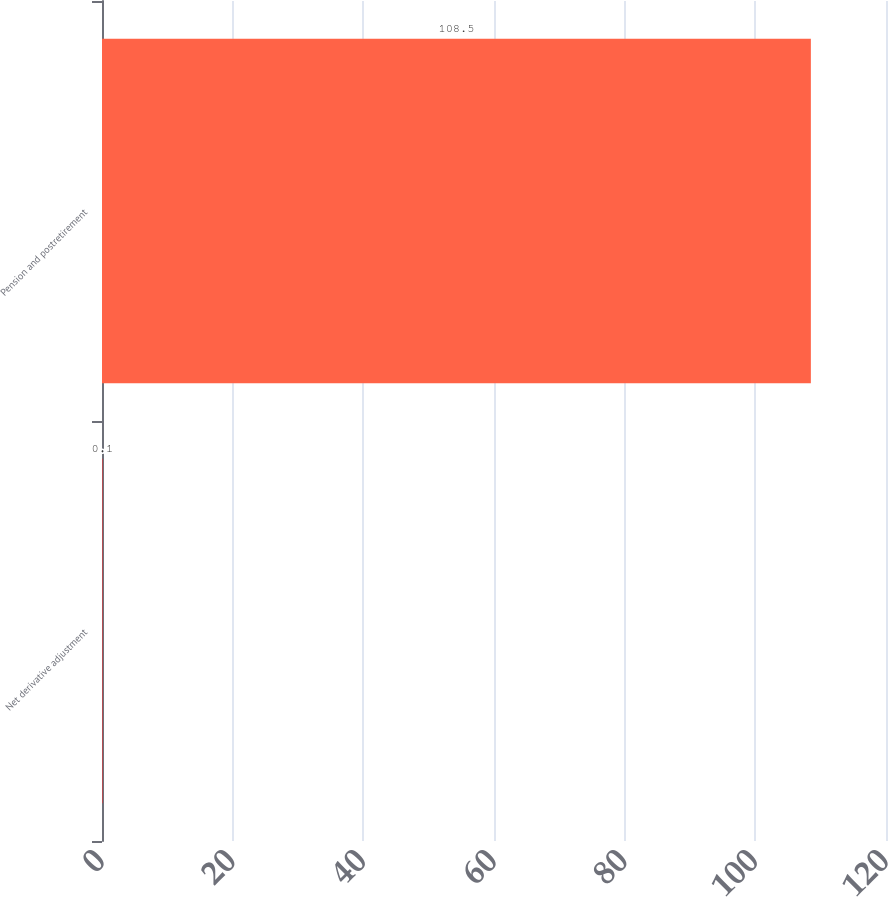Convert chart. <chart><loc_0><loc_0><loc_500><loc_500><bar_chart><fcel>Net derivative adjustment<fcel>Pension and postretirement<nl><fcel>0.1<fcel>108.5<nl></chart> 